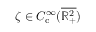Convert formula to latex. <formula><loc_0><loc_0><loc_500><loc_500>\zeta \in C _ { c } ^ { \infty } ( \overline { { \mathbb { R } _ { + } ^ { 2 } } } )</formula> 